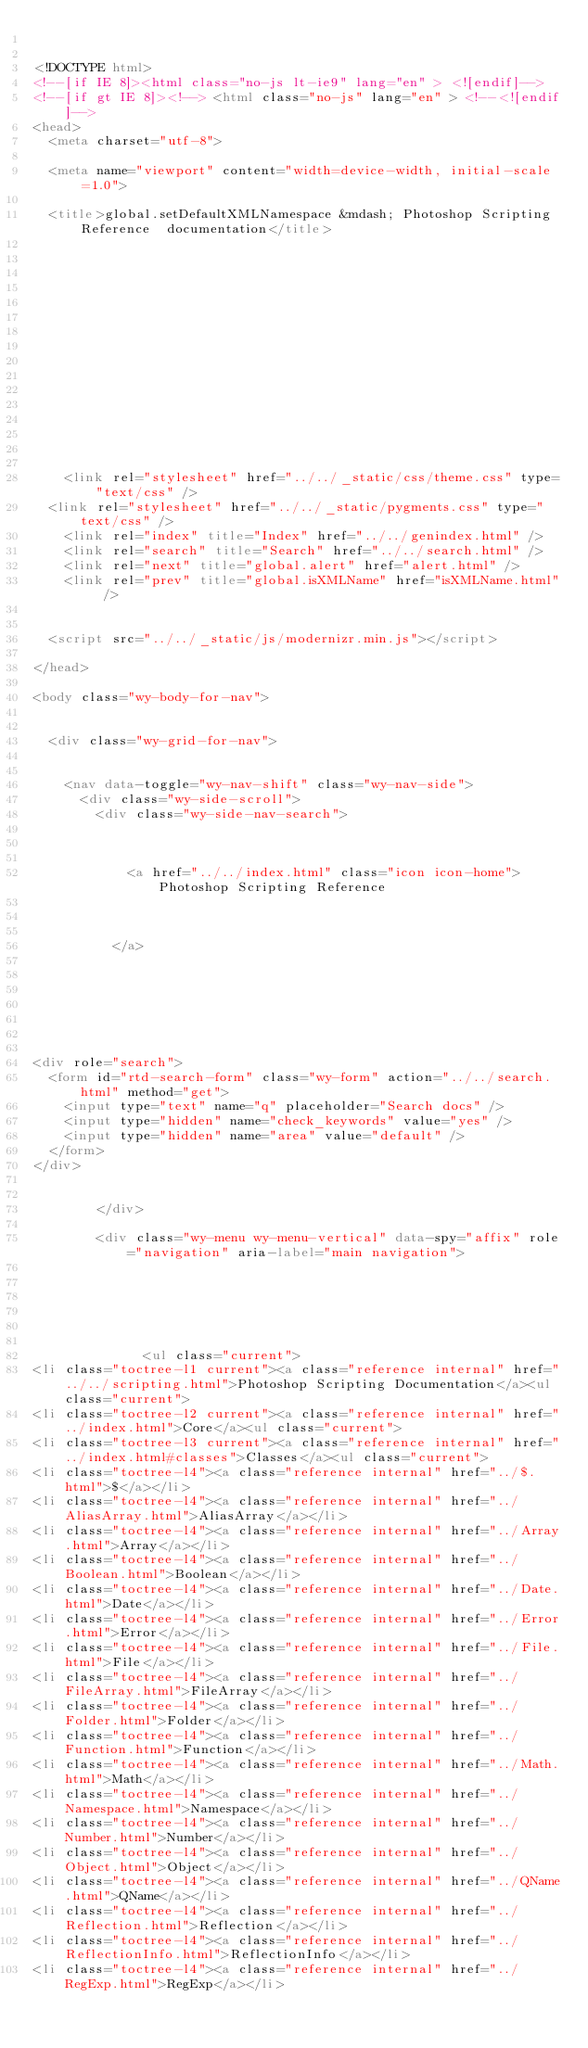<code> <loc_0><loc_0><loc_500><loc_500><_HTML_>

<!DOCTYPE html>
<!--[if IE 8]><html class="no-js lt-ie9" lang="en" > <![endif]-->
<!--[if gt IE 8]><!--> <html class="no-js" lang="en" > <!--<![endif]-->
<head>
  <meta charset="utf-8">
  
  <meta name="viewport" content="width=device-width, initial-scale=1.0">
  
  <title>global.setDefaultXMLNamespace &mdash; Photoshop Scripting Reference  documentation</title>
  

  
  
  
  

  

  
  
    

  

  
    <link rel="stylesheet" href="../../_static/css/theme.css" type="text/css" />
  <link rel="stylesheet" href="../../_static/pygments.css" type="text/css" />
    <link rel="index" title="Index" href="../../genindex.html" />
    <link rel="search" title="Search" href="../../search.html" />
    <link rel="next" title="global.alert" href="alert.html" />
    <link rel="prev" title="global.isXMLName" href="isXMLName.html" /> 

  
  <script src="../../_static/js/modernizr.min.js"></script>

</head>

<body class="wy-body-for-nav">

   
  <div class="wy-grid-for-nav">

    
    <nav data-toggle="wy-nav-shift" class="wy-nav-side">
      <div class="wy-side-scroll">
        <div class="wy-side-nav-search">
          

          
            <a href="../../index.html" class="icon icon-home"> Photoshop Scripting Reference
          

          
          </a>

          
            
            
          

          
<div role="search">
  <form id="rtd-search-form" class="wy-form" action="../../search.html" method="get">
    <input type="text" name="q" placeholder="Search docs" />
    <input type="hidden" name="check_keywords" value="yes" />
    <input type="hidden" name="area" value="default" />
  </form>
</div>

          
        </div>

        <div class="wy-menu wy-menu-vertical" data-spy="affix" role="navigation" aria-label="main navigation">
          
            
            
              
            
            
              <ul class="current">
<li class="toctree-l1 current"><a class="reference internal" href="../../scripting.html">Photoshop Scripting Documentation</a><ul class="current">
<li class="toctree-l2 current"><a class="reference internal" href="../index.html">Core</a><ul class="current">
<li class="toctree-l3 current"><a class="reference internal" href="../index.html#classes">Classes</a><ul class="current">
<li class="toctree-l4"><a class="reference internal" href="../$.html">$</a></li>
<li class="toctree-l4"><a class="reference internal" href="../AliasArray.html">AliasArray</a></li>
<li class="toctree-l4"><a class="reference internal" href="../Array.html">Array</a></li>
<li class="toctree-l4"><a class="reference internal" href="../Boolean.html">Boolean</a></li>
<li class="toctree-l4"><a class="reference internal" href="../Date.html">Date</a></li>
<li class="toctree-l4"><a class="reference internal" href="../Error.html">Error</a></li>
<li class="toctree-l4"><a class="reference internal" href="../File.html">File</a></li>
<li class="toctree-l4"><a class="reference internal" href="../FileArray.html">FileArray</a></li>
<li class="toctree-l4"><a class="reference internal" href="../Folder.html">Folder</a></li>
<li class="toctree-l4"><a class="reference internal" href="../Function.html">Function</a></li>
<li class="toctree-l4"><a class="reference internal" href="../Math.html">Math</a></li>
<li class="toctree-l4"><a class="reference internal" href="../Namespace.html">Namespace</a></li>
<li class="toctree-l4"><a class="reference internal" href="../Number.html">Number</a></li>
<li class="toctree-l4"><a class="reference internal" href="../Object.html">Object</a></li>
<li class="toctree-l4"><a class="reference internal" href="../QName.html">QName</a></li>
<li class="toctree-l4"><a class="reference internal" href="../Reflection.html">Reflection</a></li>
<li class="toctree-l4"><a class="reference internal" href="../ReflectionInfo.html">ReflectionInfo</a></li>
<li class="toctree-l4"><a class="reference internal" href="../RegExp.html">RegExp</a></li></code> 